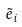Convert formula to latex. <formula><loc_0><loc_0><loc_500><loc_500>\tilde { e } _ { i }</formula> 